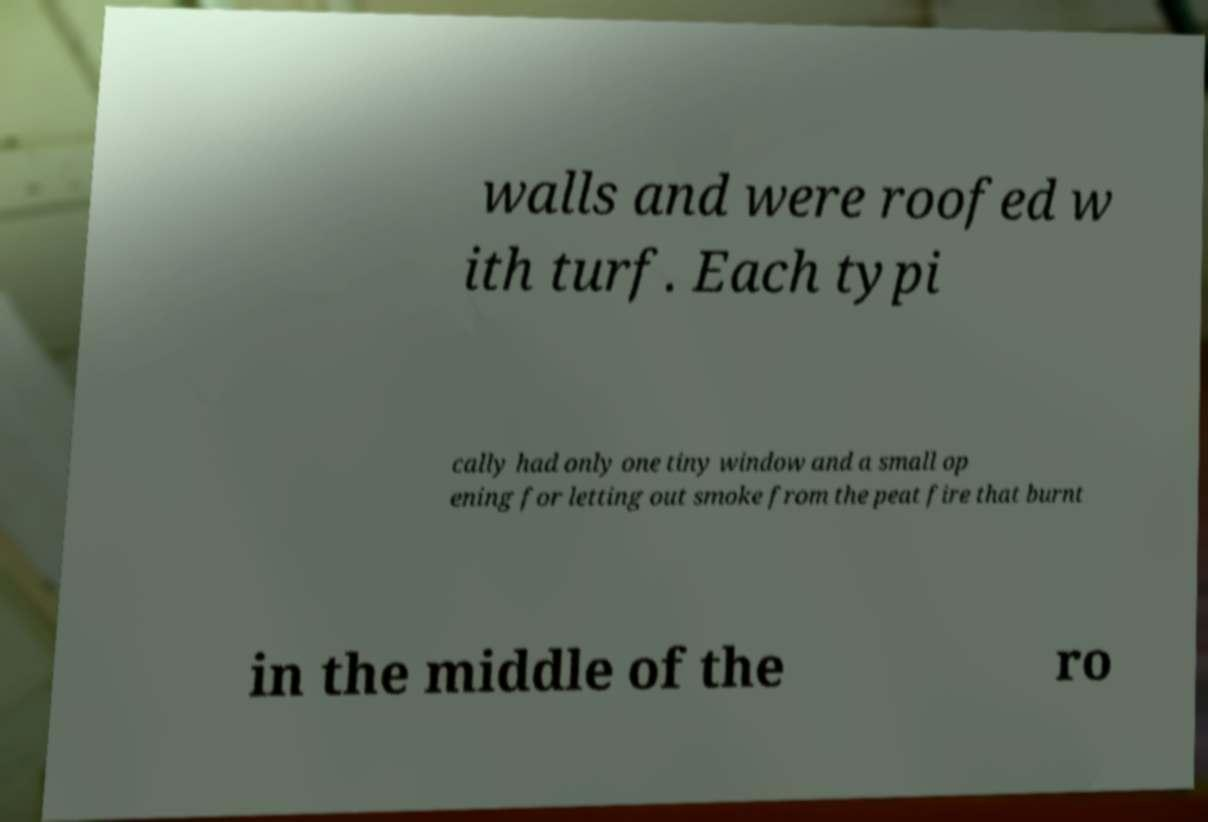Could you extract and type out the text from this image? walls and were roofed w ith turf. Each typi cally had only one tiny window and a small op ening for letting out smoke from the peat fire that burnt in the middle of the ro 